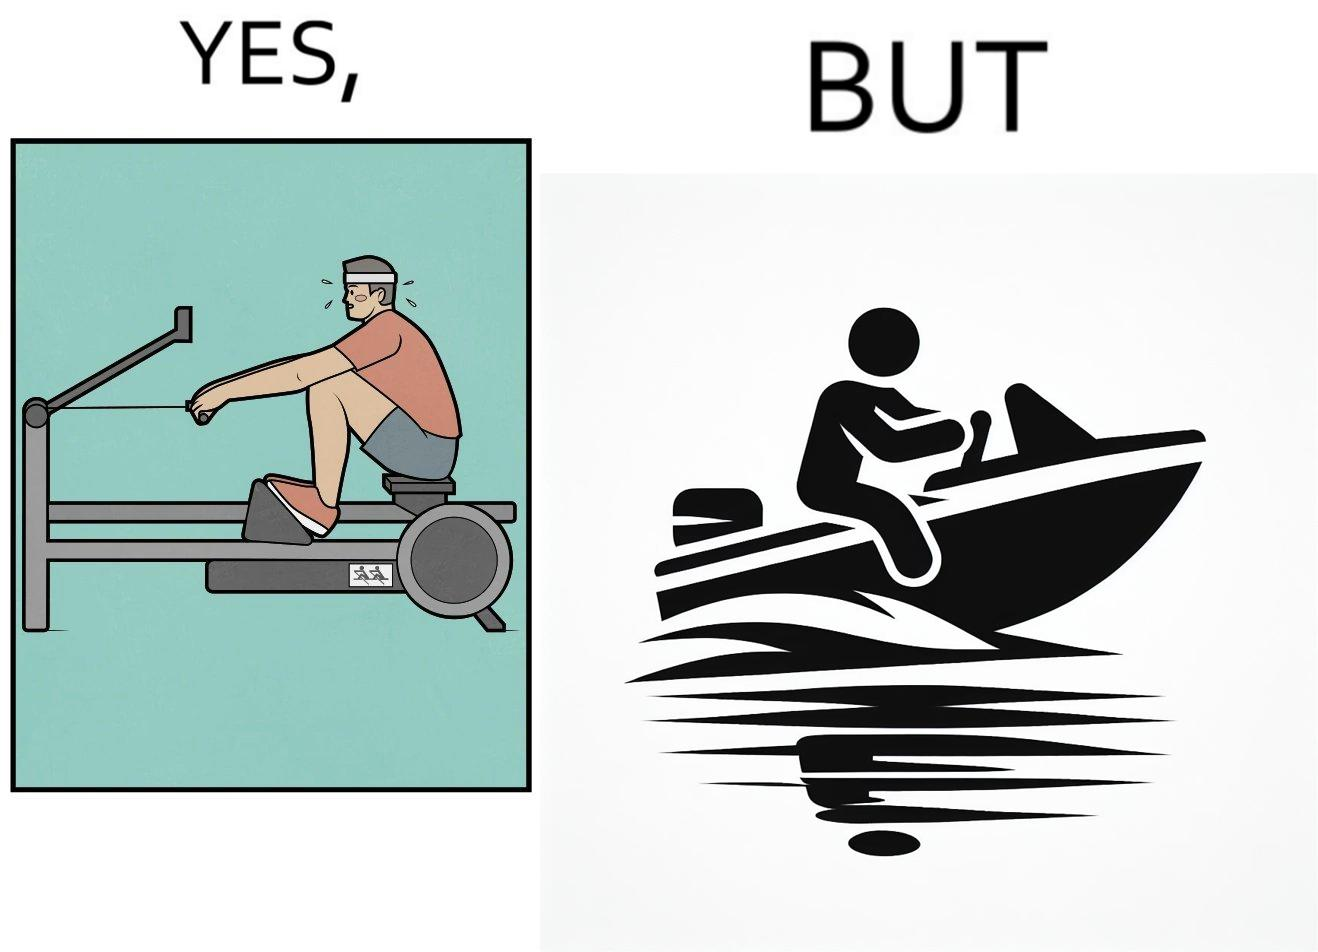What do you see in each half of this image? In the left part of the image: a person doing rowing exercise in gym In the right part of the image: a person riding a motorboat 